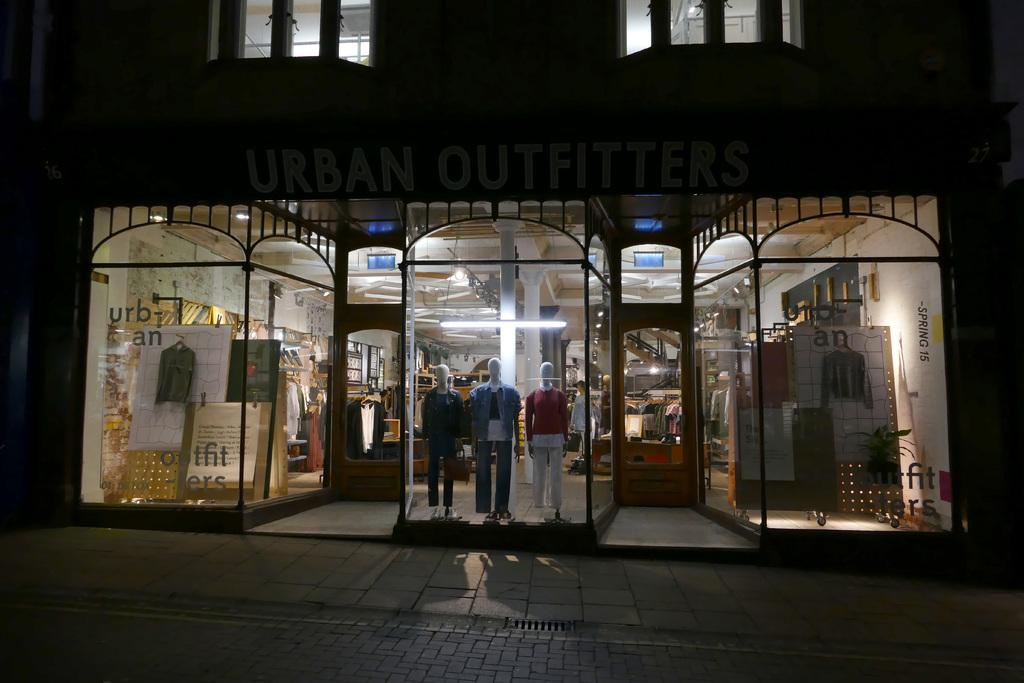What type of structure is present in the image? There is a building in the image. What features can be seen on the building? The building has windows and a door. Are there any additional objects or features in the image? Yes, there are statues, banners, and stairs in the image. What type of wine is being served at the event depicted in the image? There is no event or wine present in the image; it features a building with windows, a door, statues, banners, and stairs. How many feet are visible in the image? There are no feet visible in the image. 